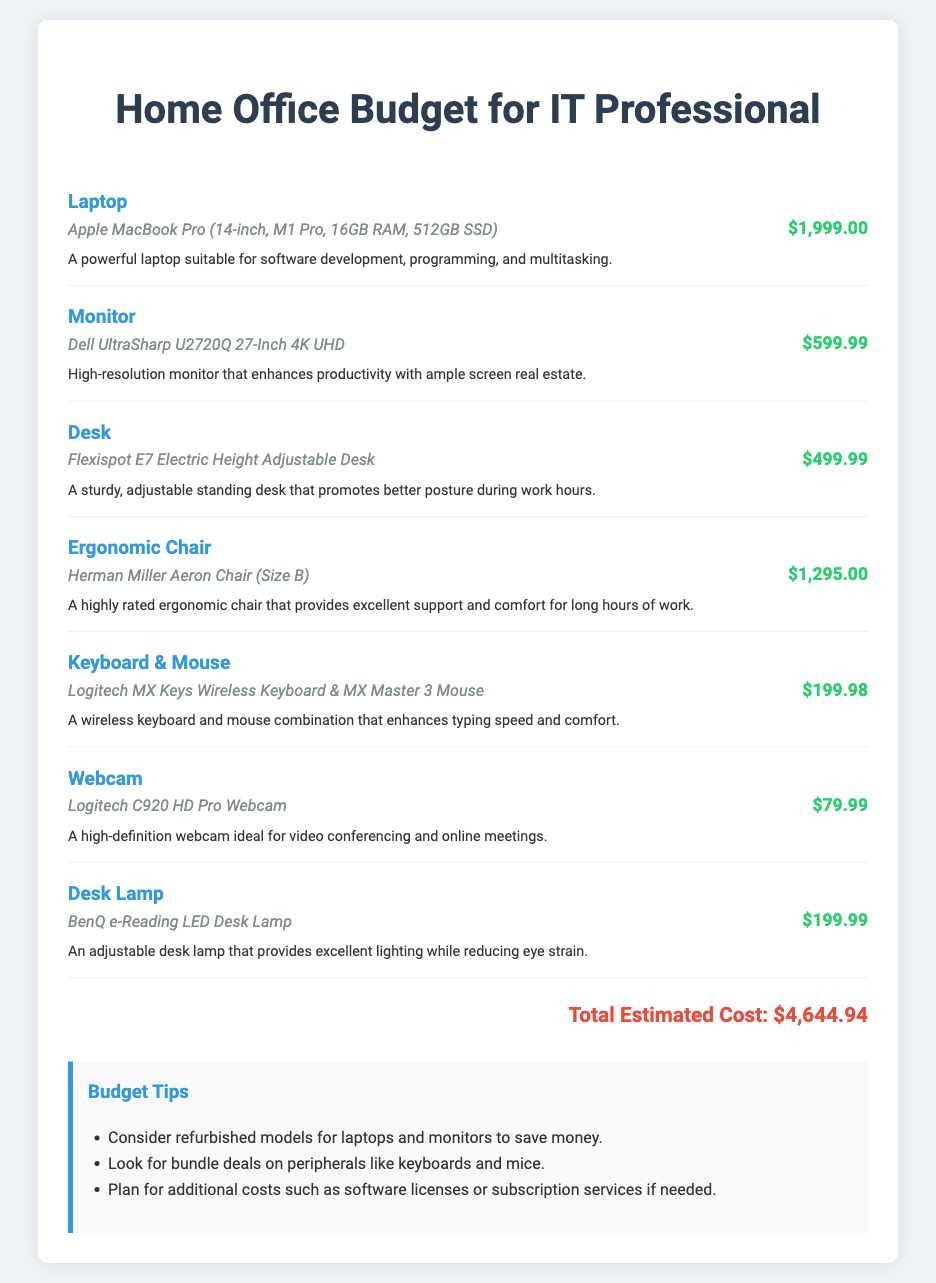What is the total estimated cost? The total estimated cost is displayed at the bottom of the document, calculated by summing all individual item costs.
Answer: $4,644.94 What model of laptop is listed? The specific model of the laptop is mentioned in the budget item for laptops.
Answer: Apple MacBook Pro (14-inch, M1 Pro, 16GB RAM, 512GB SSD) How much does the ergonomic chair cost? The cost of the ergonomic chair is specified separately in its budget item.
Answer: $1,295.00 What is the purpose of the desk lamp described? The purpose of the desk lamp is outlined in its item description, focusing on its functionality.
Answer: Excellent lighting while reducing eye strain How many items are listed in the budget? The total number of items is determined by counting each budget item presented in the document.
Answer: 7 Which monitor model is included in the budget? The document explicitly states the model of the monitor under the budget item for monitors.
Answer: Dell UltraSharp U2720Q 27-Inch 4K UHD What brand of keyboard and mouse is recommended? The document specifies the brand in the budget item for the keyboard and mouse.
Answer: Logitech What is one budget tip provided? The document lists several tips for budgeting, of which any single one can be mentioned.
Answer: Consider refurbished models for laptops and monitors to save money 